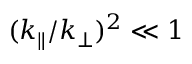Convert formula to latex. <formula><loc_0><loc_0><loc_500><loc_500>( k _ { \| } / k _ { \perp } ) ^ { 2 } \ll 1</formula> 